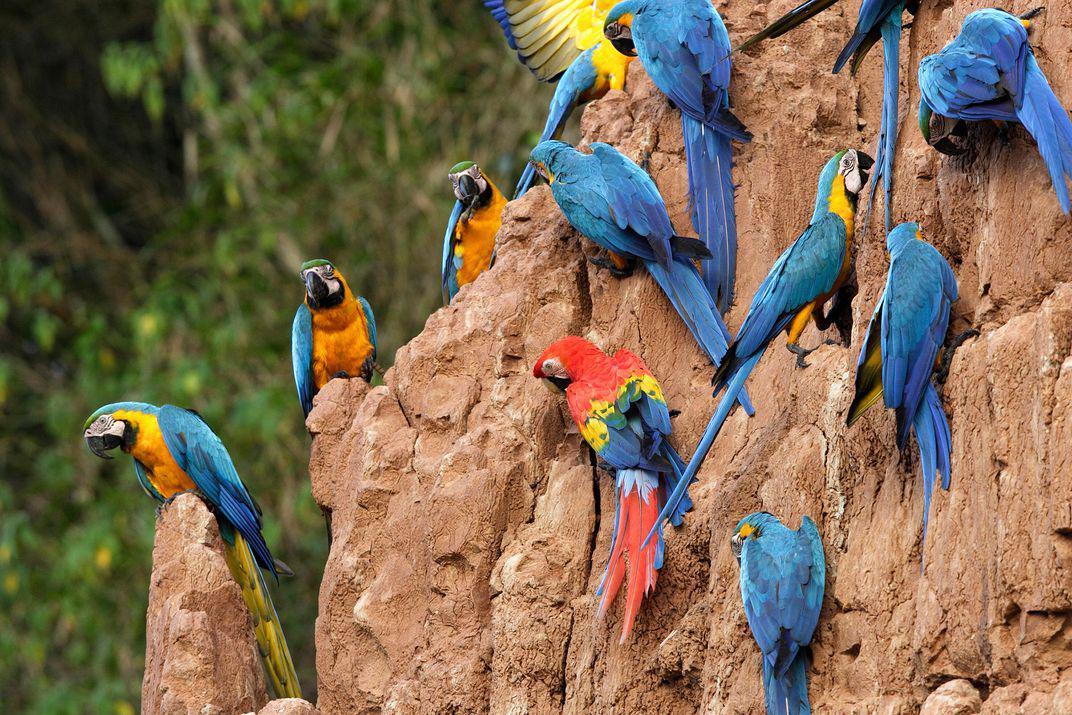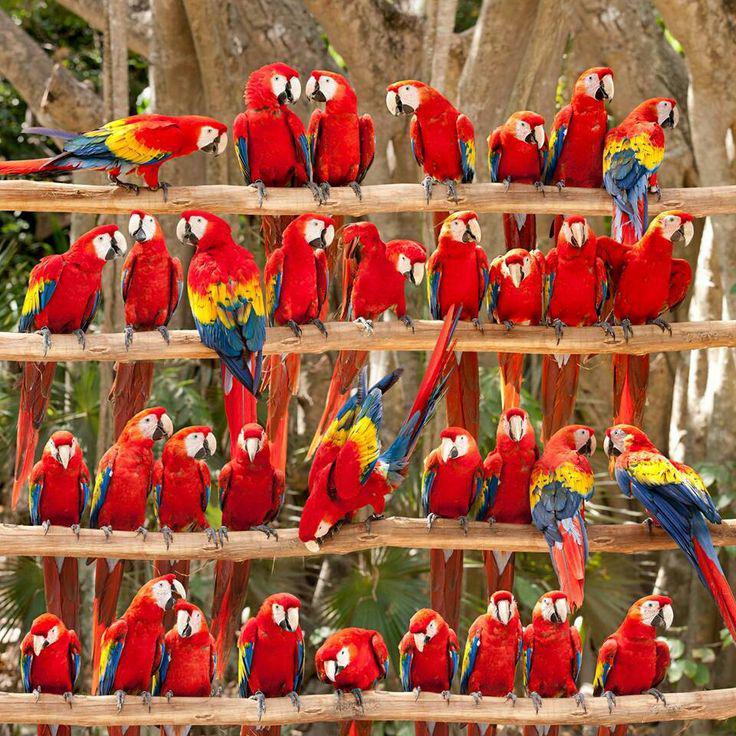The first image is the image on the left, the second image is the image on the right. Examine the images to the left and right. Is the description "An image shows a single red-headed bird, which is in flight with its body at a diagonal angle." accurate? Answer yes or no. No. The first image is the image on the left, the second image is the image on the right. For the images displayed, is the sentence "There is no more than one parrot in the left image." factually correct? Answer yes or no. No. 